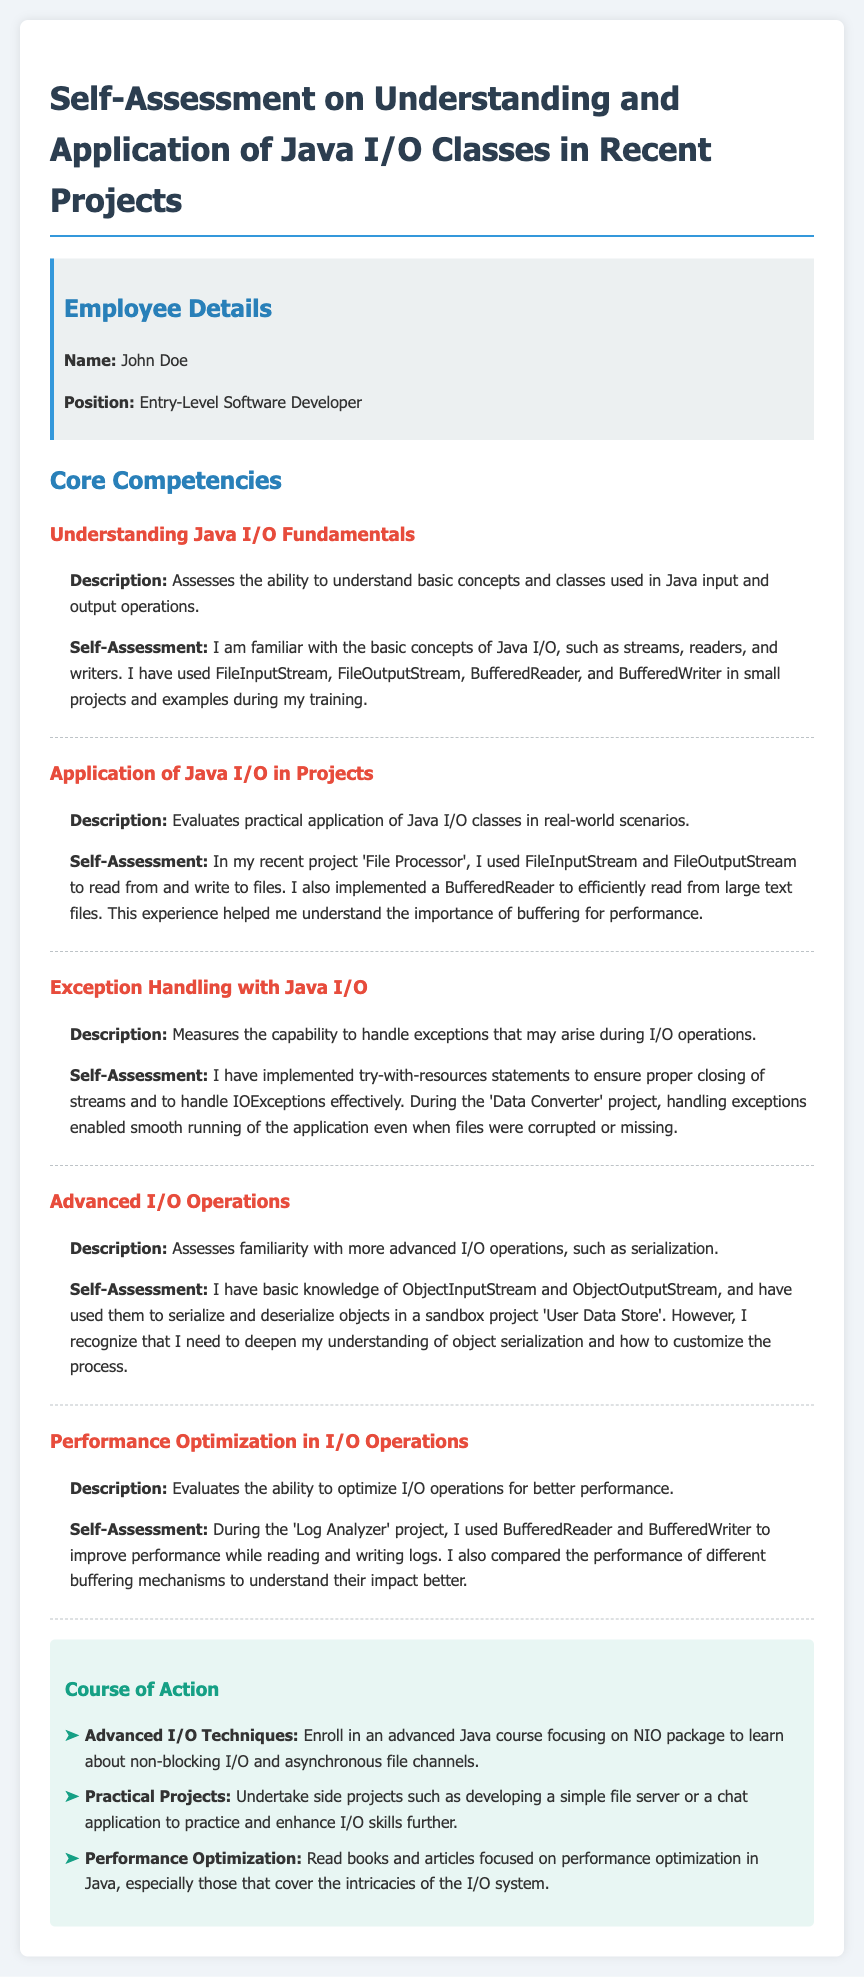what is the name of the employee? The name of the employee is mentioned in the employee details section of the document.
Answer: John Doe what position does the employee hold? The position of the employee is specified in the employee details section.
Answer: Entry-Level Software Developer which Java I/O classes did the employee use in the 'File Processor' project? This information can be found in the section that describes the application of Java I/O in projects.
Answer: FileInputStream and FileOutputStream what exception handling technique is mentioned in the document? The document describes an exception handling technique used by the employee within the context of their projects.
Answer: try-with-resources statements which project involved handling corrupted files? The project where the employee dealt with corrupted files is specified under exception handling with Java I/O.
Answer: Data Converter what advanced I/O concept does the employee plan to learn more about? This concept is discussed in the advanced I/O operations section of the document.
Answer: object serialization how did the employee improve performance during I/O operations in the 'Log Analyzer' project? The document states a specific technique used by the employee to enhance I/O performance.
Answer: BufferedReader and BufferedWriter what course of action does the employee suggest for improving I/O skills? The course of action is mentioned in the suggestions section for further development of skills.
Answer: Enroll in an advanced Java course focusing on NIO package 